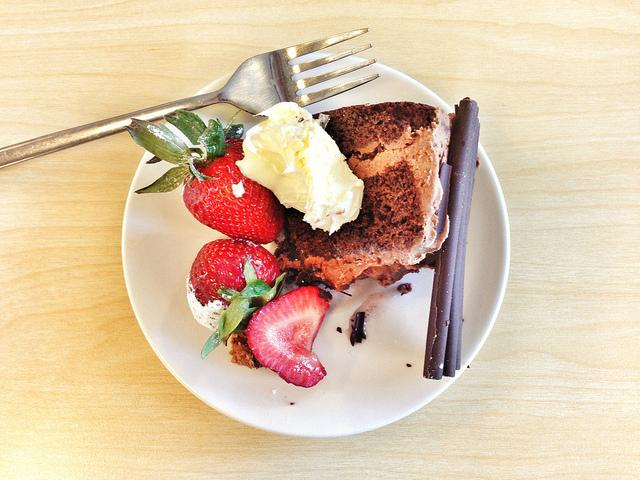What kind of fruit is there a serving of to the side of the cake? strawberry 